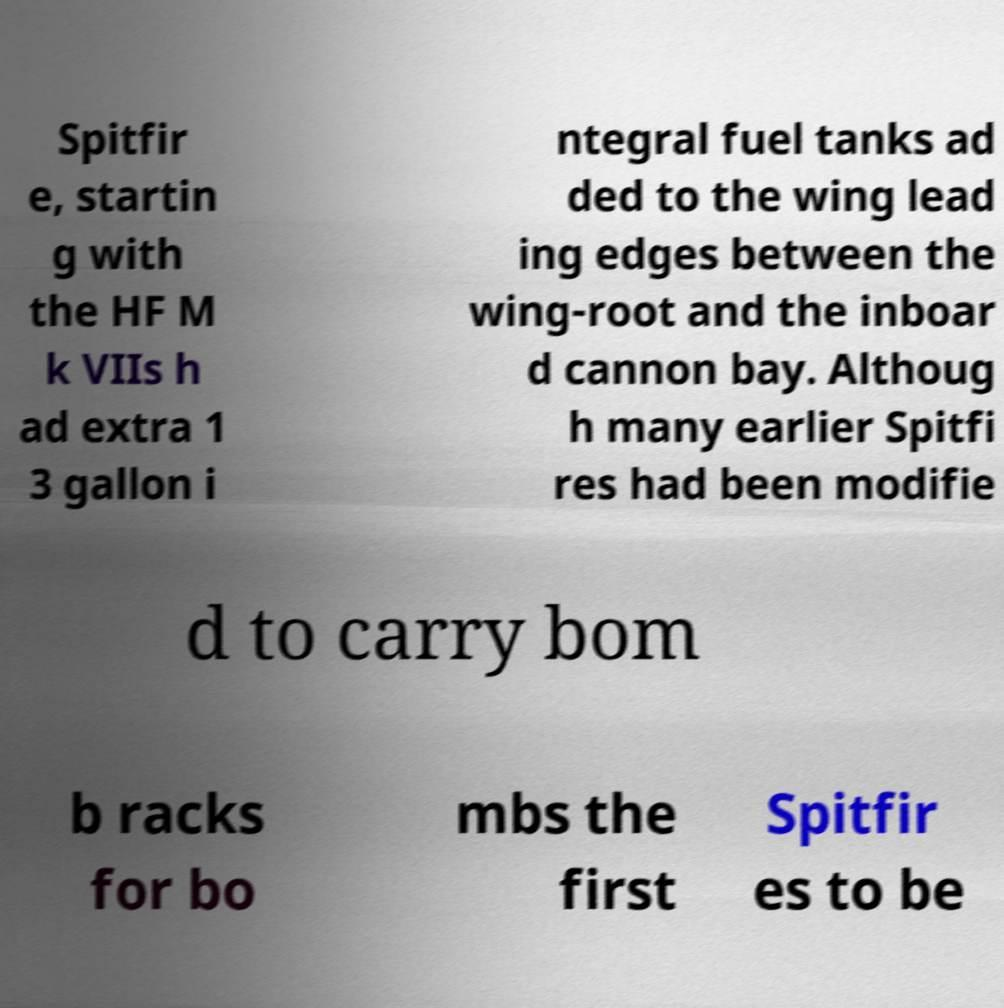There's text embedded in this image that I need extracted. Can you transcribe it verbatim? Spitfir e, startin g with the HF M k VIIs h ad extra 1 3 gallon i ntegral fuel tanks ad ded to the wing lead ing edges between the wing-root and the inboar d cannon bay. Althoug h many earlier Spitfi res had been modifie d to carry bom b racks for bo mbs the first Spitfir es to be 